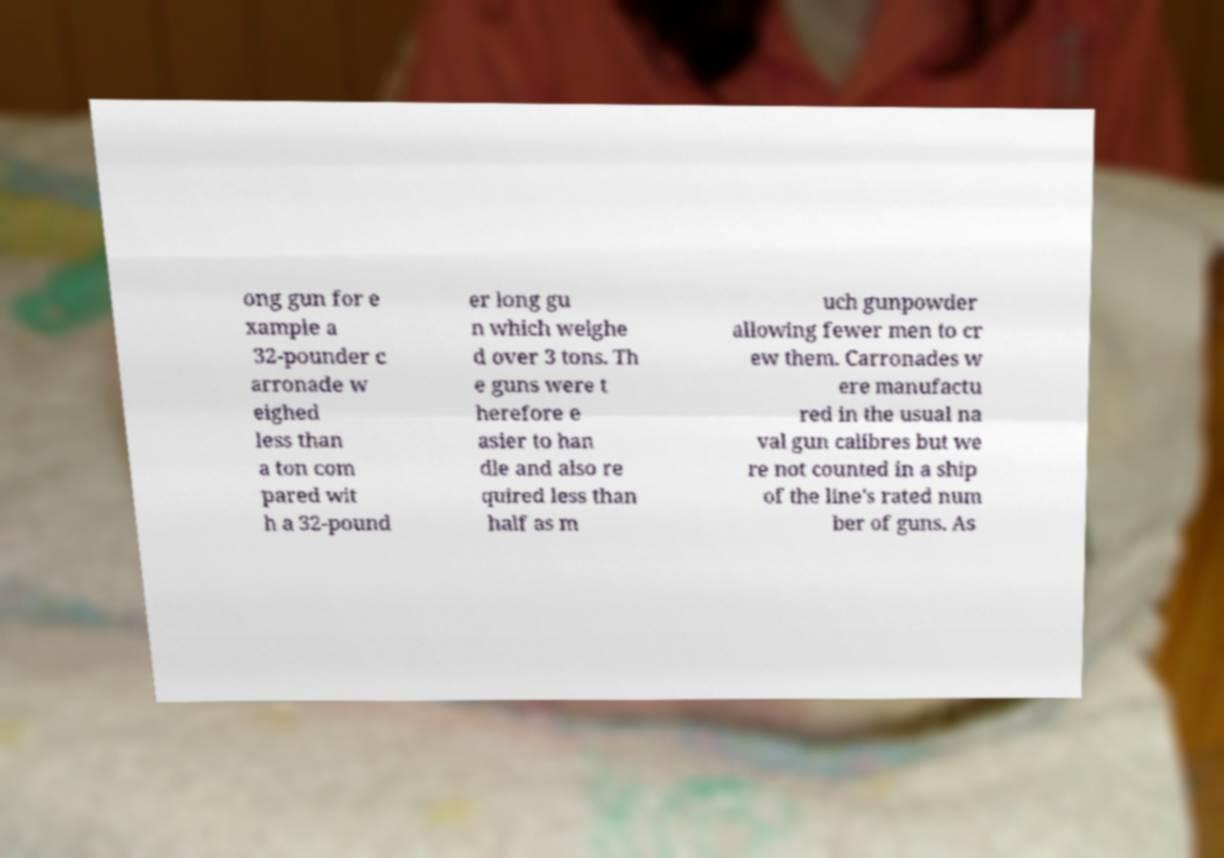Could you extract and type out the text from this image? ong gun for e xample a 32-pounder c arronade w eighed less than a ton com pared wit h a 32-pound er long gu n which weighe d over 3 tons. Th e guns were t herefore e asier to han dle and also re quired less than half as m uch gunpowder allowing fewer men to cr ew them. Carronades w ere manufactu red in the usual na val gun calibres but we re not counted in a ship of the line's rated num ber of guns. As 